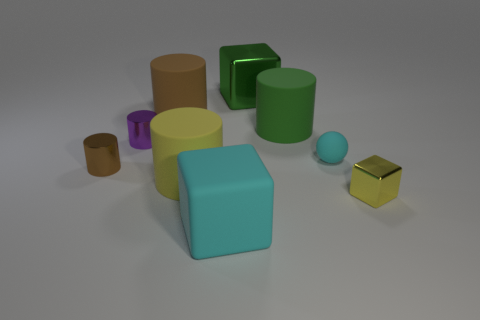What shape is the small brown metal thing that is to the left of the large cyan rubber cube? The small brown object located to the left of the large cyan rubber cube is indeed a cylinder. It has a height that is roughly equal to its diameter, typical of a cylindrical shape. 